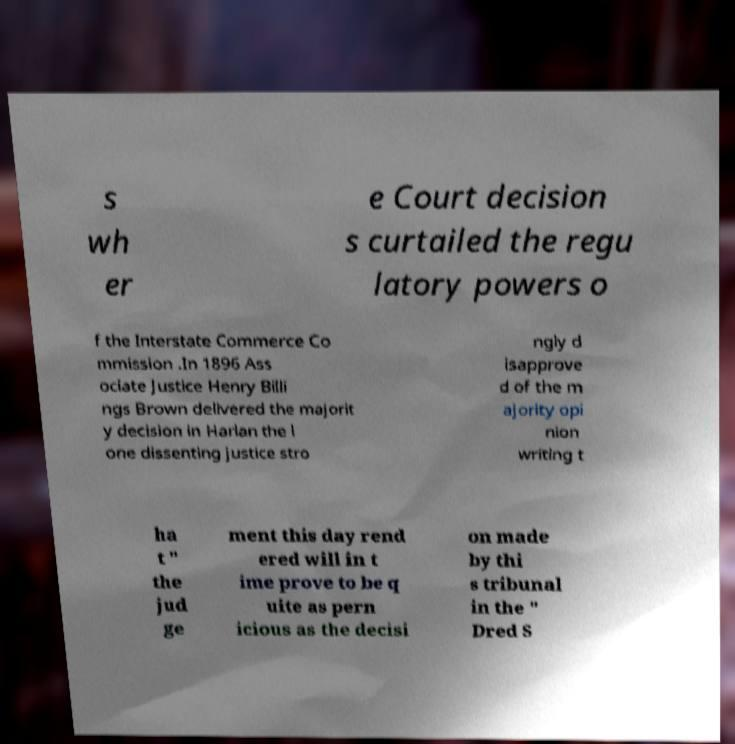Please read and relay the text visible in this image. What does it say? s wh er e Court decision s curtailed the regu latory powers o f the Interstate Commerce Co mmission .In 1896 Ass ociate Justice Henry Billi ngs Brown delivered the majorit y decision in Harlan the l one dissenting justice stro ngly d isapprove d of the m ajority opi nion writing t ha t " the jud ge ment this day rend ered will in t ime prove to be q uite as pern icious as the decisi on made by thi s tribunal in the " Dred S 